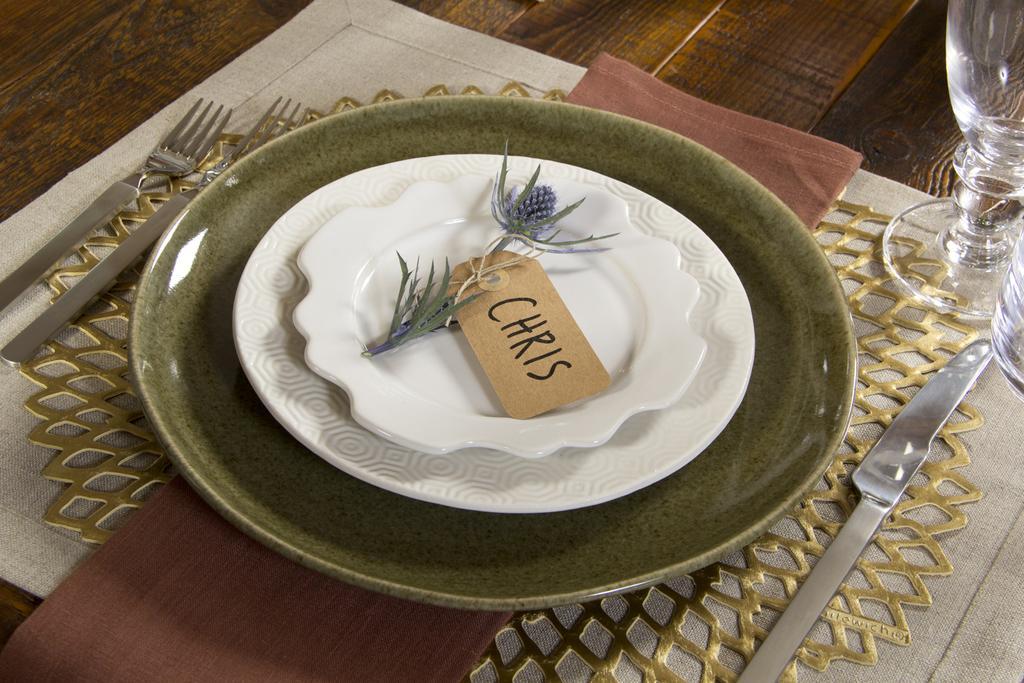Describe this image in one or two sentences. In this image we can see few plates. There are few forks at the left side of the image. There is a knife at the right side of the image. There are few drinking glasses in the image. There is a wooden object in the image. 